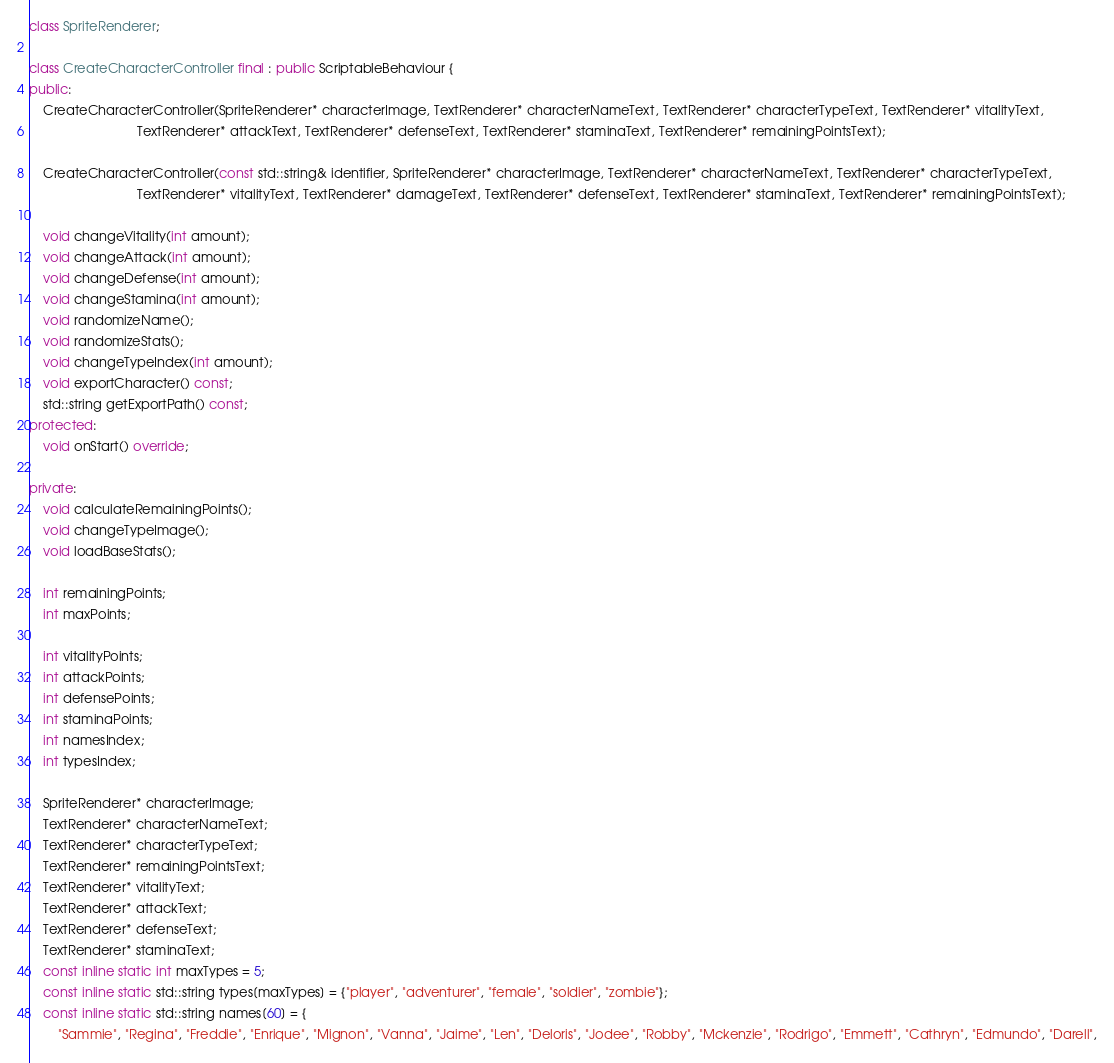<code> <loc_0><loc_0><loc_500><loc_500><_C++_>class SpriteRenderer;

class CreateCharacterController final : public ScriptableBehaviour {
public:
    CreateCharacterController(SpriteRenderer* characterImage, TextRenderer* characterNameText, TextRenderer* characterTypeText, TextRenderer* vitalityText,
                              TextRenderer* attackText, TextRenderer* defenseText, TextRenderer* staminaText, TextRenderer* remainingPointsText);

    CreateCharacterController(const std::string& identifier, SpriteRenderer* characterImage, TextRenderer* characterNameText, TextRenderer* characterTypeText,
                              TextRenderer* vitalityText, TextRenderer* damageText, TextRenderer* defenseText, TextRenderer* staminaText, TextRenderer* remainingPointsText);

    void changeVitality(int amount);
    void changeAttack(int amount);
    void changeDefense(int amount);
    void changeStamina(int amount);
    void randomizeName();
    void randomizeStats();
    void changeTypeIndex(int amount);
    void exportCharacter() const;
    std::string getExportPath() const;
protected:
    void onStart() override;

private:
    void calculateRemainingPoints();
    void changeTypeImage();
    void loadBaseStats();

    int remainingPoints;
    int maxPoints;

    int vitalityPoints;
    int attackPoints;
    int defensePoints;
    int staminaPoints;
    int namesIndex;
    int typesIndex;

    SpriteRenderer* characterImage;
    TextRenderer* characterNameText;
    TextRenderer* characterTypeText;
    TextRenderer* remainingPointsText;
    TextRenderer* vitalityText;
    TextRenderer* attackText;
    TextRenderer* defenseText;
    TextRenderer* staminaText;
    const inline static int maxTypes = 5;
    const inline static std::string types[maxTypes] = {"player", "adventurer", "female", "soldier", "zombie"};
    const inline static std::string names[60] = {
        "Sammie", "Regina", "Freddie", "Enrique", "Mignon", "Vanna", "Jaime", "Len", "Deloris", "Jodee", "Robby", "Mckenzie", "Rodrigo", "Emmett", "Cathryn", "Edmundo", "Darell",</code> 